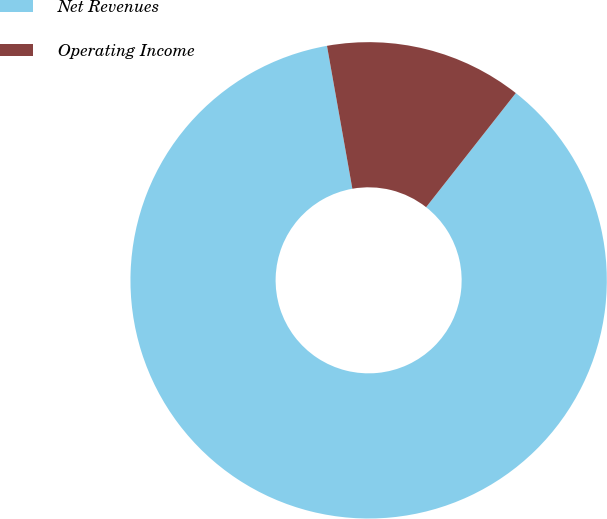Convert chart to OTSL. <chart><loc_0><loc_0><loc_500><loc_500><pie_chart><fcel>Net Revenues<fcel>Operating Income<nl><fcel>86.6%<fcel>13.4%<nl></chart> 